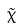Convert formula to latex. <formula><loc_0><loc_0><loc_500><loc_500>\tilde { \chi }</formula> 